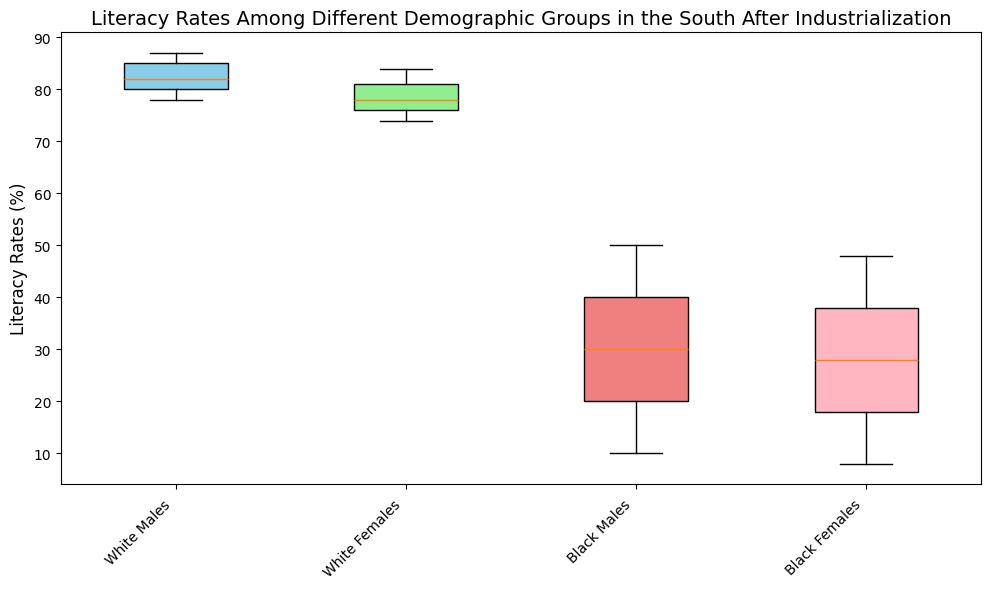What's the average literacy rate for White Males from 1860 to 1900? First, identify the values for White Males: 78, 80, 82, 85, 87. Sum these values to get 78 + 80 + 82 + 85 + 87 = 412. Then, divide by the number of data points, which is 5. The average is 412 / 5 = 82.4.
Answer: 82.4 Which demographic group shows the highest median literacy rate? The box plot allows us to identify the median as the line inside each box. For White Males and White Females, it's quite clear they are higher compared to Black Males and Black Females. Among White Males and White Females, the median of White Males appears slightly higher.
Answer: White Males Is the interquartile range (IQR) for Black Females less than that for Black Males? The IQR is the range between the first quartile (25th percentile) and third quartile (75th percentile). Visually inspecting the plots, the IQR for Black Females seems to be from around 18 to 38, while for Black Males, it appears to follow the same range. Hence, they are equal, not less.
Answer: No Which demographic group has the widest spread in literacy rates? Spread can be gauged by the length of the box in the box plot, which represents the IQR. By visual inspection, Black Males and Black Females have wider spreads compared to White Males and White Females. Between the two, Black Females appear to have a slightly wider box.
Answer: Black Females What is the difference in the median literacy rates of White Females and Black Females? The median literacy rates for White Females and Black Females are visually identified from the box plots. White Females have a median in the low 80s, while Black Females have it around 28. Calculating the difference: 82 (approx) - 28 = 54.
Answer: 54 Are the literacy rates of Black Males and Black Females in 1900 above or below the median for White Females? The 1900 literacy rates for Black Males and Black Females are 50 and 48, respectively. The median for White Females is around 78. Hence, both groups are below the median for White Females.
Answer: Below Which demographic group's literacy rates increased the most over the period? Considering the range from the lower to upper end of the box, Black Males and Black Females have the greatest increase in literacy rates, rising from approximately 10 and 8 to 50 and 48, respectively. Black Females' range increased from 8 to 48 (an increment of 40).
Answer: Black Females 